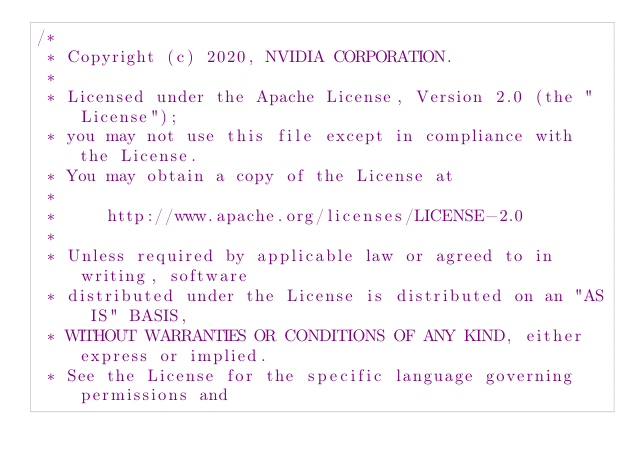Convert code to text. <code><loc_0><loc_0><loc_500><loc_500><_Cuda_>/*
 * Copyright (c) 2020, NVIDIA CORPORATION.
 *
 * Licensed under the Apache License, Version 2.0 (the "License");
 * you may not use this file except in compliance with the License.
 * You may obtain a copy of the License at
 *
 *     http://www.apache.org/licenses/LICENSE-2.0
 *
 * Unless required by applicable law or agreed to in writing, software
 * distributed under the License is distributed on an "AS IS" BASIS,
 * WITHOUT WARRANTIES OR CONDITIONS OF ANY KIND, either express or implied.
 * See the License for the specific language governing permissions and</code> 